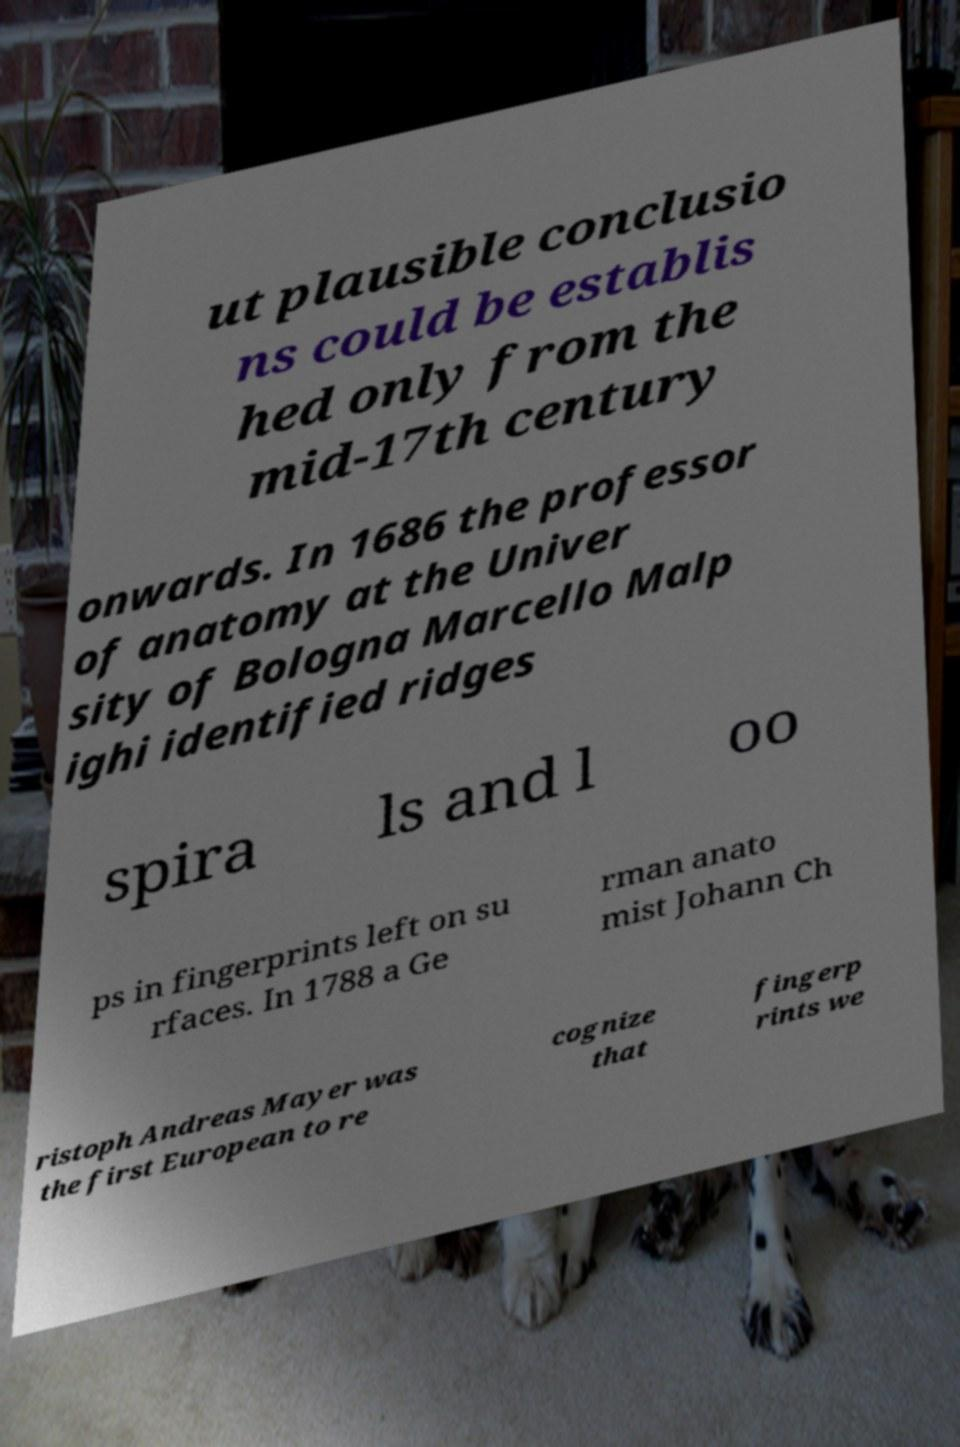Please identify and transcribe the text found in this image. ut plausible conclusio ns could be establis hed only from the mid-17th century onwards. In 1686 the professor of anatomy at the Univer sity of Bologna Marcello Malp ighi identified ridges spira ls and l oo ps in fingerprints left on su rfaces. In 1788 a Ge rman anato mist Johann Ch ristoph Andreas Mayer was the first European to re cognize that fingerp rints we 